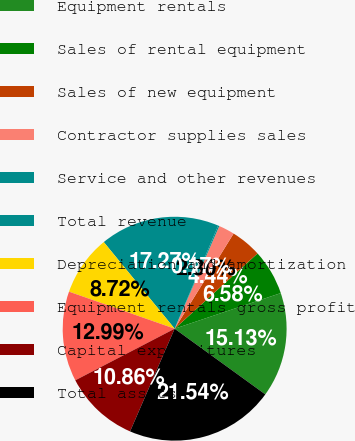Convert chart to OTSL. <chart><loc_0><loc_0><loc_500><loc_500><pie_chart><fcel>Equipment rentals<fcel>Sales of rental equipment<fcel>Sales of new equipment<fcel>Contractor supplies sales<fcel>Service and other revenues<fcel>Total revenue<fcel>Depreciation and amortization<fcel>Equipment rentals gross profit<fcel>Capital expenditures<fcel>Total assets<nl><fcel>15.13%<fcel>6.58%<fcel>4.44%<fcel>2.3%<fcel>0.17%<fcel>17.27%<fcel>8.72%<fcel>12.99%<fcel>10.86%<fcel>21.54%<nl></chart> 